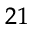Convert formula to latex. <formula><loc_0><loc_0><loc_500><loc_500>_ { 2 1 }</formula> 